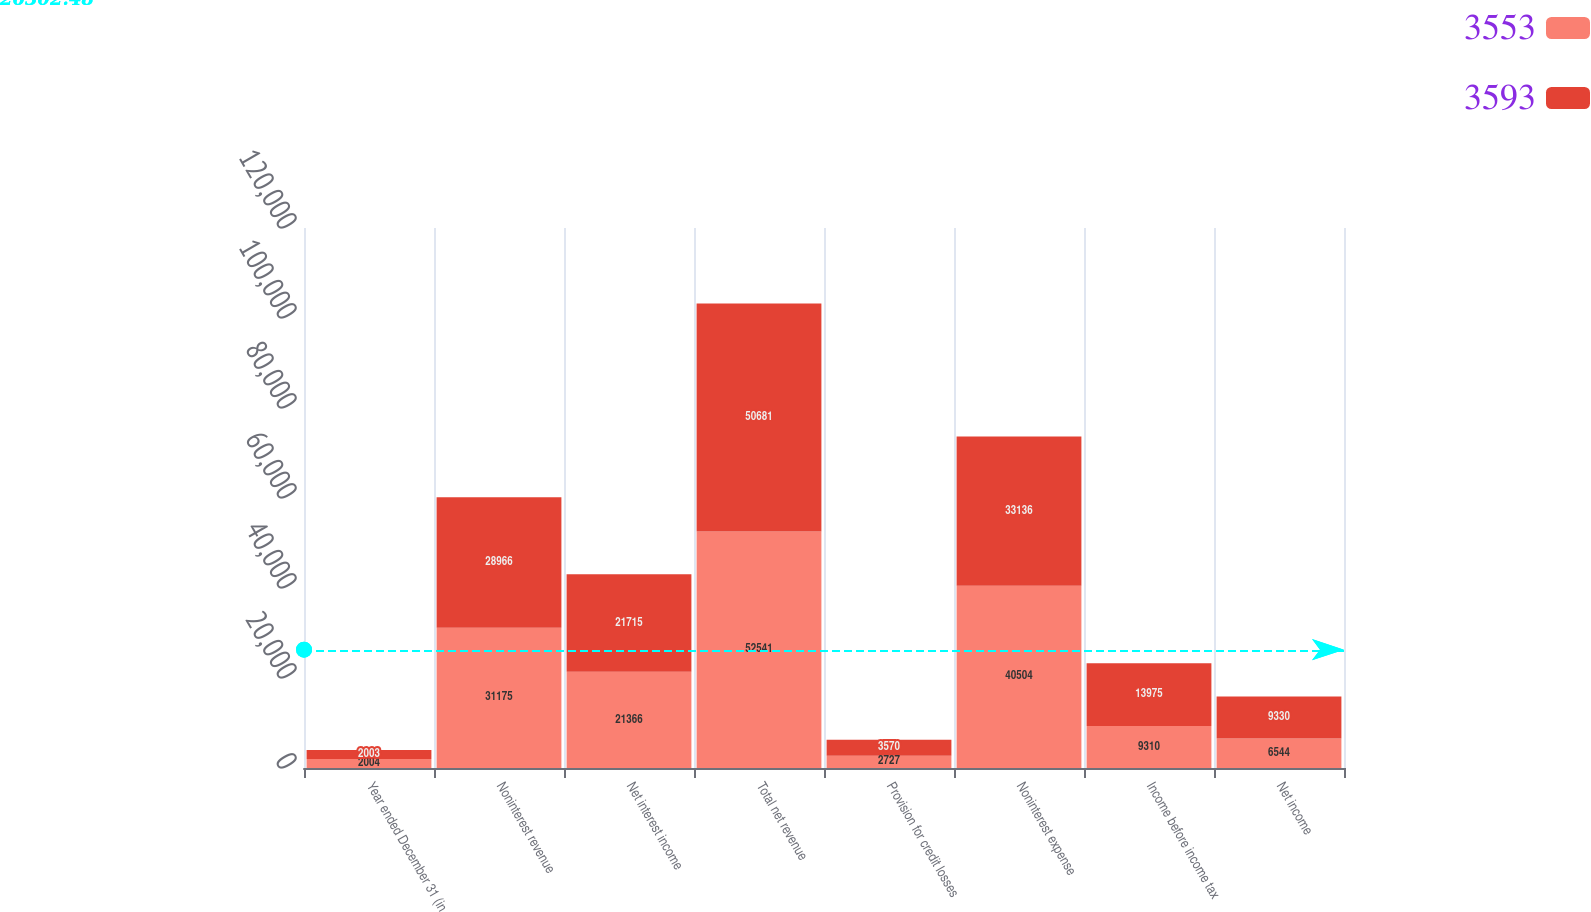Convert chart. <chart><loc_0><loc_0><loc_500><loc_500><stacked_bar_chart><ecel><fcel>Year ended December 31 (in<fcel>Noninterest revenue<fcel>Net interest income<fcel>Total net revenue<fcel>Provision for credit losses<fcel>Noninterest expense<fcel>Income before income tax<fcel>Net income<nl><fcel>3553<fcel>2004<fcel>31175<fcel>21366<fcel>52541<fcel>2727<fcel>40504<fcel>9310<fcel>6544<nl><fcel>3593<fcel>2003<fcel>28966<fcel>21715<fcel>50681<fcel>3570<fcel>33136<fcel>13975<fcel>9330<nl></chart> 